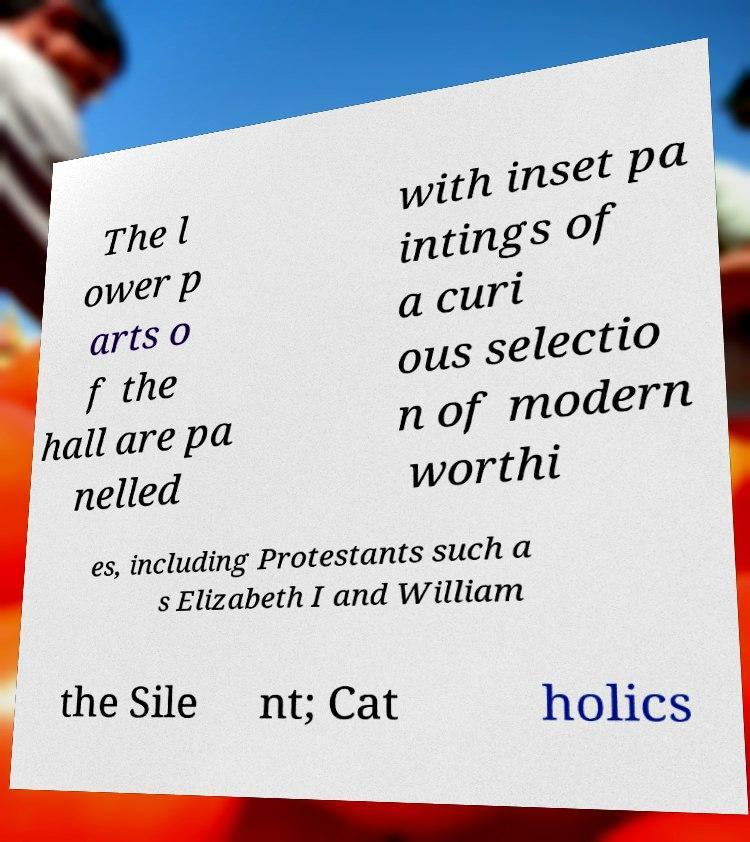Please identify and transcribe the text found in this image. The l ower p arts o f the hall are pa nelled with inset pa intings of a curi ous selectio n of modern worthi es, including Protestants such a s Elizabeth I and William the Sile nt; Cat holics 